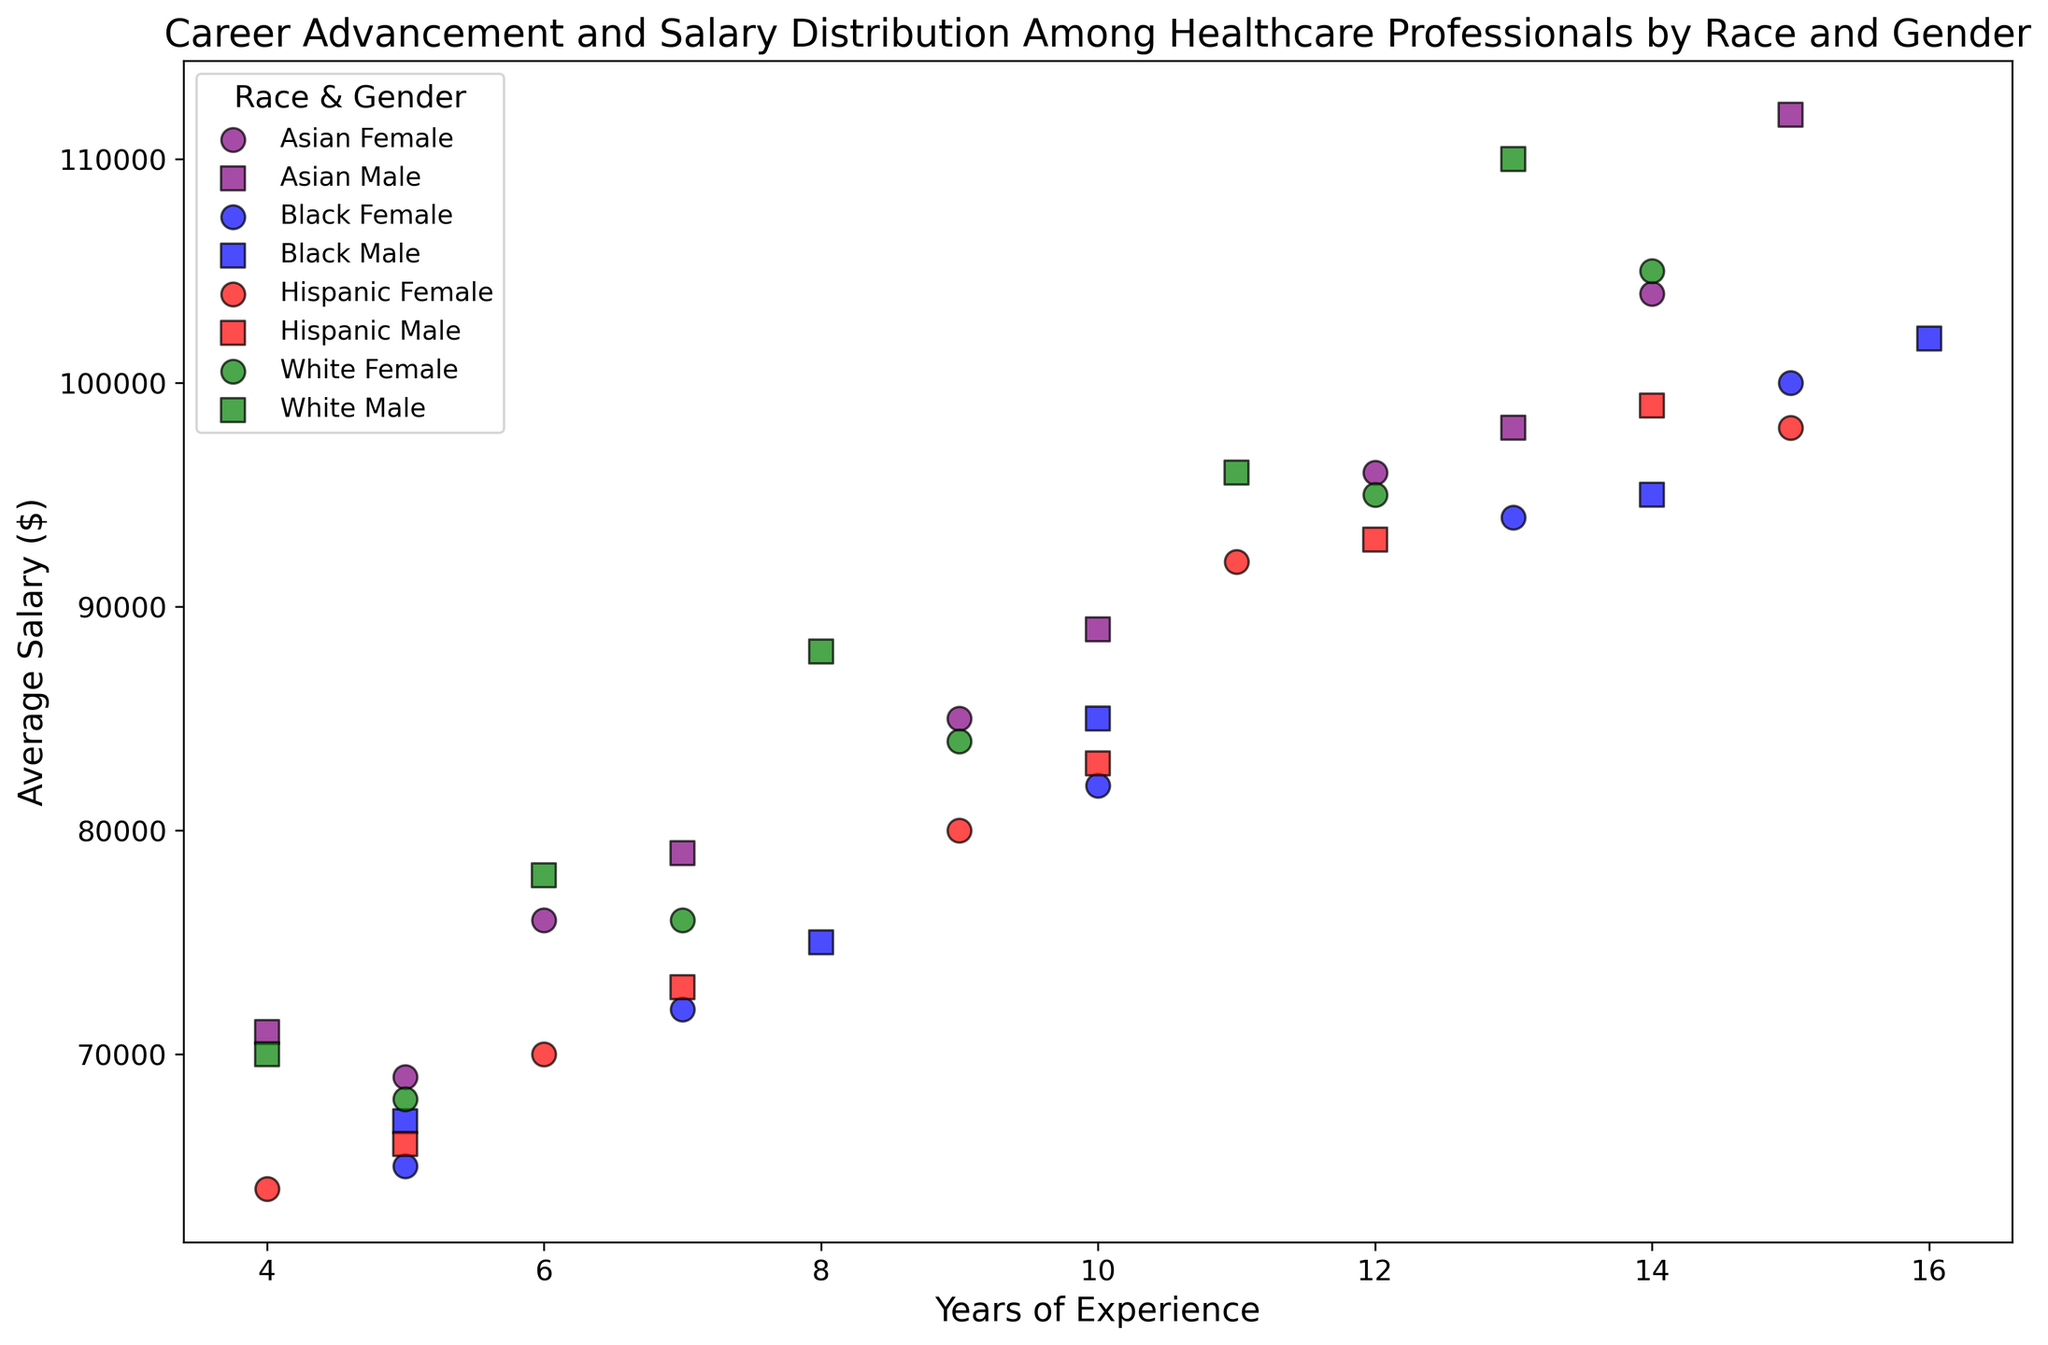What is the highest average salary among all groups? By observing the y-axis, the highest average salary is indicated by the data point with the greatest y-value. The data point with $112,000 is the highest.
Answer: $112,000 Which gender tends to have higher average salaries within the Black racial group? We compare the positions of the blue (Black) female circles and squares across the y-axis. Most blue squares (males) are slightly above the blue circles (females).
Answer: Male Is there a visible difference in salary between Asian females and Hispanic males with the same years of experience? We compare the purple circles (Asian females) and red squares (Hispanic males) along the y-axis for each x-value (years of experience). For instance, at 5 years, Asian females have $69,000 whereas Hispanic males have $66,000.
Answer: Yes, Asian females tend to have slightly higher salaries Which group has the lowest starting salary at 4 years of experience? Comparing the y-values at x = 4, we find that the Hispanic females (red circles) have an average salary of $64,000, which is the lowest among the groups.
Answer: Hispanic Female Are males generally earning more than females among the White racial group with more than 10 years of experience? We can visually inspect the green circles and squares (Whites). For experience greater than 10 years, White males consistently have higher salaries compared to White females.
Answer: Yes What is the difference in average salary between the highest and lowest salaries within the Asian racial group? The highest salary for Asian males is $112,000 while for Asian females it's $104,000. The lowest for Asian males is $71,000 and for Asian females $69,000. The differences are $41,000 for males and $35,000 for females.
Answer: $41,000 (Male), $35,000 (Female) How does average salary increase with years of experience among Black females compared to Black males? By tracking the slope of the trend for blue circles (females) vs blue squares (males), it appears that both slopes are relatively similar, indicating similar growth in average salary with experience.
Answer: Similar Is there a group that consistently has higher average salaries across all years of experience compared to others? By observing all markers at various experience levels (x-axis), the purple squares (Asian males) generally sit above the others, indicating higher salaries overall.
Answer: Asian Male At 10 years of experience, which racial group shows the highest variability in average salaries between genders? Observing the y-axis at x=10, the green markers (White racial group) have a significant difference between the circle and square markers' positions, showing high variability.
Answer: White 